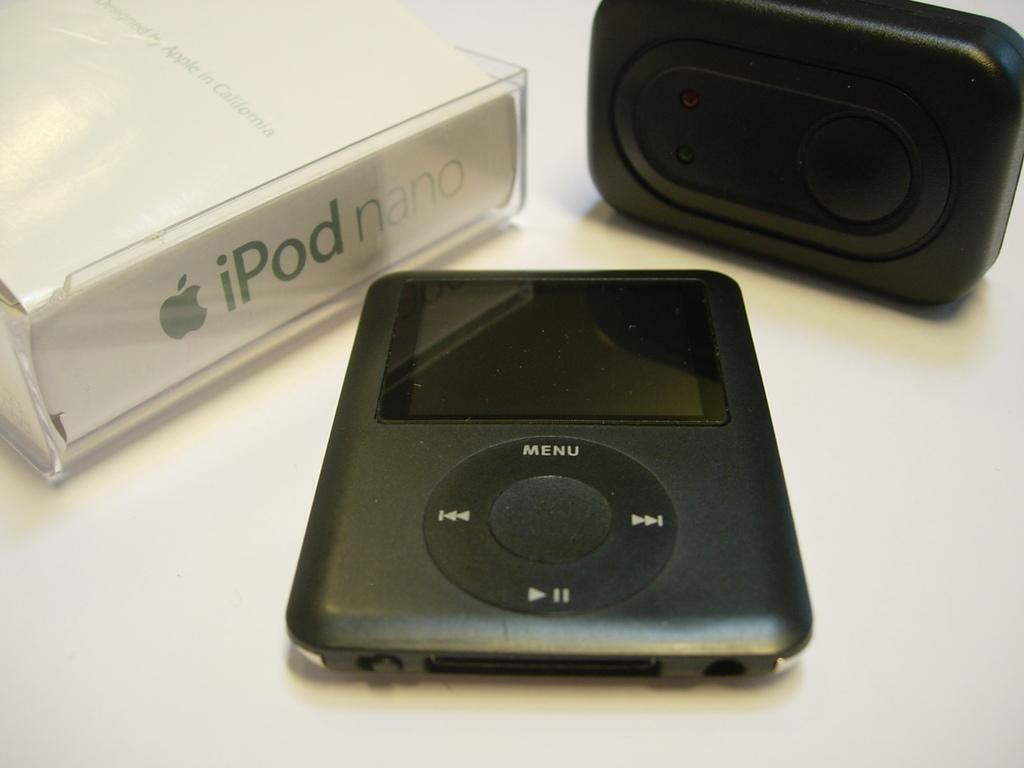Please provide a concise description of this image. In this picture we can see two devices and a box and these three are placed on a platform. 